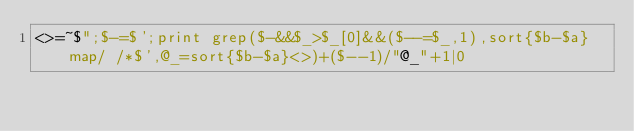<code> <loc_0><loc_0><loc_500><loc_500><_Perl_><>=~$";$-=$';print grep($-&&$_>$_[0]&&($--=$_,1),sort{$b-$a}map/ /*$',@_=sort{$b-$a}<>)+($--1)/"@_"+1|0</code> 